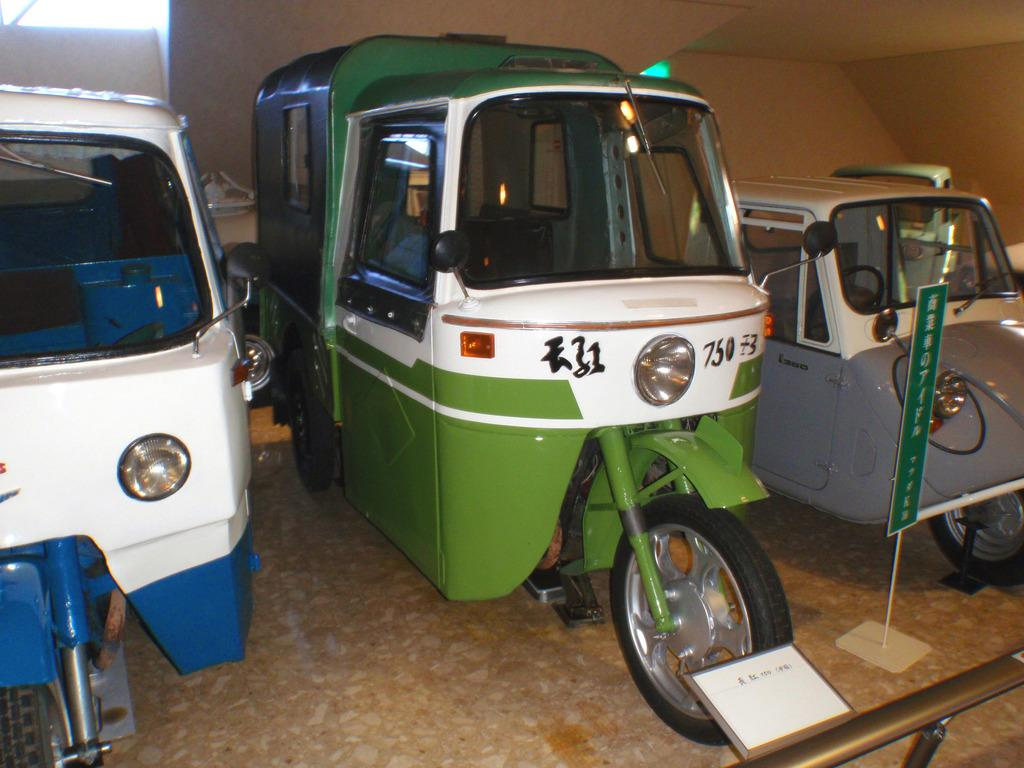What colors are the autos in the image? The autos in the image are green and white. What is the condition of the autos in the image? The autos are parked. What is present in the front of the image? There is a steel railing and board in the front of the image. What can be seen in the background of the image? There is a wall in the background of the image. What type of honey is being harvested from the autos in the image? There is no honey or honey harvesting activity present in the image; it features parked autos with a steel railing and board in the front and a wall in the background. 